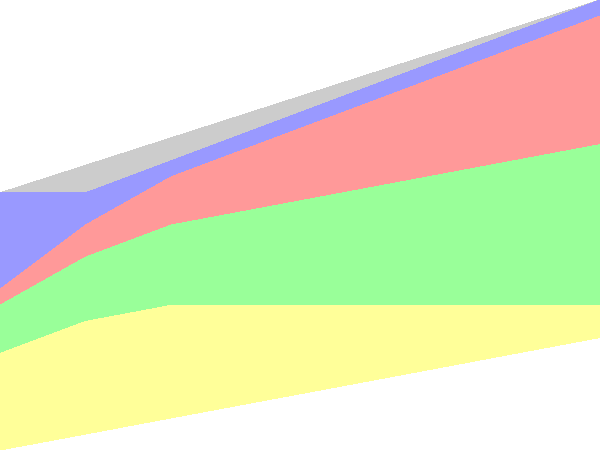Analyzing the stacked area chart depicting the evolution of book genres from 1950 to 2020, which genre shows the most significant decline in market share over the entire period? To determine which genre has declined the most over the entire period, we need to compare the starting and ending points for each genre:

1. Fiction: Increases from 20% to 55%, so no decline.
2. Non-Fiction: Starts at 30% and ends at 10%, a decline of 20 percentage points.
3. Mystery: Increases from 15% to 50%, so no decline.
4. Sci-Fi: Increases from 5% to 40%, so no decline.
5. Other: Starts at 30% and ends at 5%, a decline of 25 percentage points.

Comparing the declines:
- Non-Fiction: 20 percentage points
- Other: 25 percentage points

The "Other" category shows the largest decline of 25 percentage points over the entire period from 1950 to 2020.
Answer: Other 